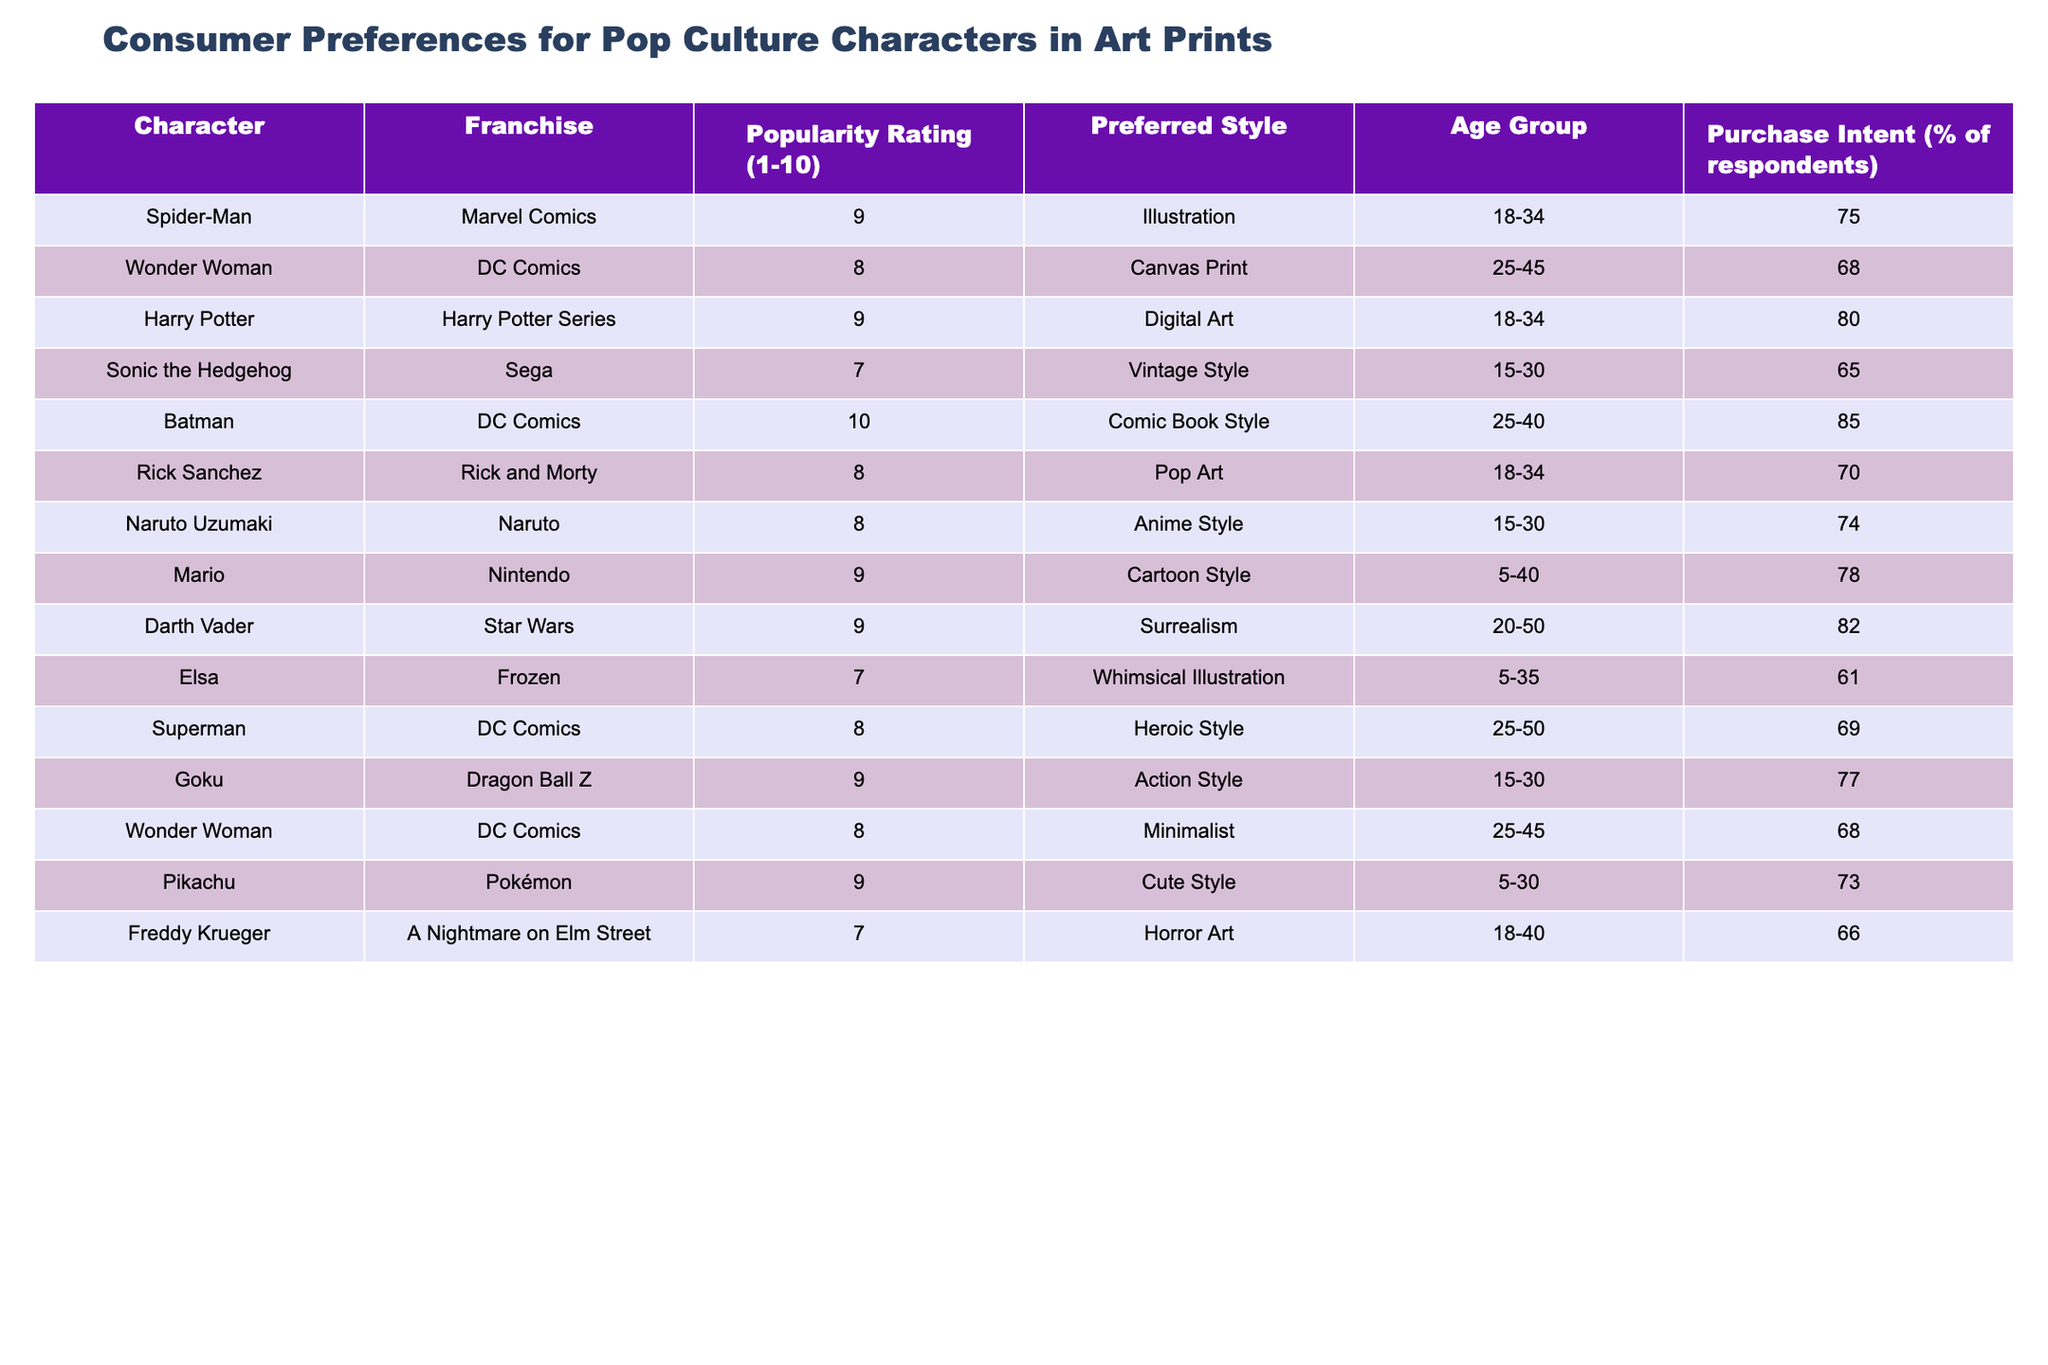What is the highest popularity rating among the characters? Looking at the "Popularity Rating (1-10)" column, Batman has the highest rating of 10.
Answer: 10 Which character has the highest purchase intent percentage? By examining the "Purchase Intent (% of respondents)" column, Batman has the highest purchase intent at 85%.
Answer: 85% What is the preferred style of Harry Potter in art prints? In the "Preferred Style" column for Harry Potter, it is listed as "Digital Art."
Answer: Digital Art Are there any characters with a purchase intent percentage below 65%? Reviewing the "Purchase Intent (% of respondents)" column, the only character with a percentage below 65% is Elsa at 61%. Therefore, the answer is yes.
Answer: Yes What is the average popularity rating for characters from DC Comics? The popularity ratings for DC Comics characters are 8 (Wonder Woman), 10 (Batman), 8 (Superman), and 8 (Wonder Woman again). The average is calculated as (8 + 10 + 8 + 8) / 4 = 34 / 4 = 8.5.
Answer: 8.5 How many characters have a popularity rating of 9 or above? Looking at the "Popularity Rating (1-10)" column, the characters with a rating of 9 or above are Spider-Man, Harry Potter, Batman, Naruto Uzumaki, Mario, Darth Vader, Goku, and Pikachu, totaling 8 characters.
Answer: 8 Which franchise has the character with the lowest preference rating? The character with the lowest preference rating is Sonic the Hedgehog from the Sega franchise with a rating of 7.
Answer: Sega What is the purchase intent percentage for characters in the age group of 25-45? The characters in this age group are Wonder Woman (68%), Batman (85%), and Superman (69%). The average purchase intent for this group can be found by calculating (68 + 85 + 69) / 3 = 220 / 3 = 73.33%.
Answer: 73.33% Which character has the same purchase intent as Wonder Woman? The purchase intent percentage for Wonder Woman is 68%. By comparing with the other characters, the second Wonder Woman also has a purchase intent percentage of 68%.
Answer: Second Wonder Woman What is the difference in purchase intent between Batman and Spider-Man? The purchase intents are 85% for Batman and 75% for Spider-Man. The difference is calculated as 85 - 75 = 10%.
Answer: 10% Is the preferred style for Goku the same as for Naruto Uzumaki? Goku's preferred style is "Action Style," while Naruto Uzumaki's is "Anime Style." Therefore, they are not the same.
Answer: No 